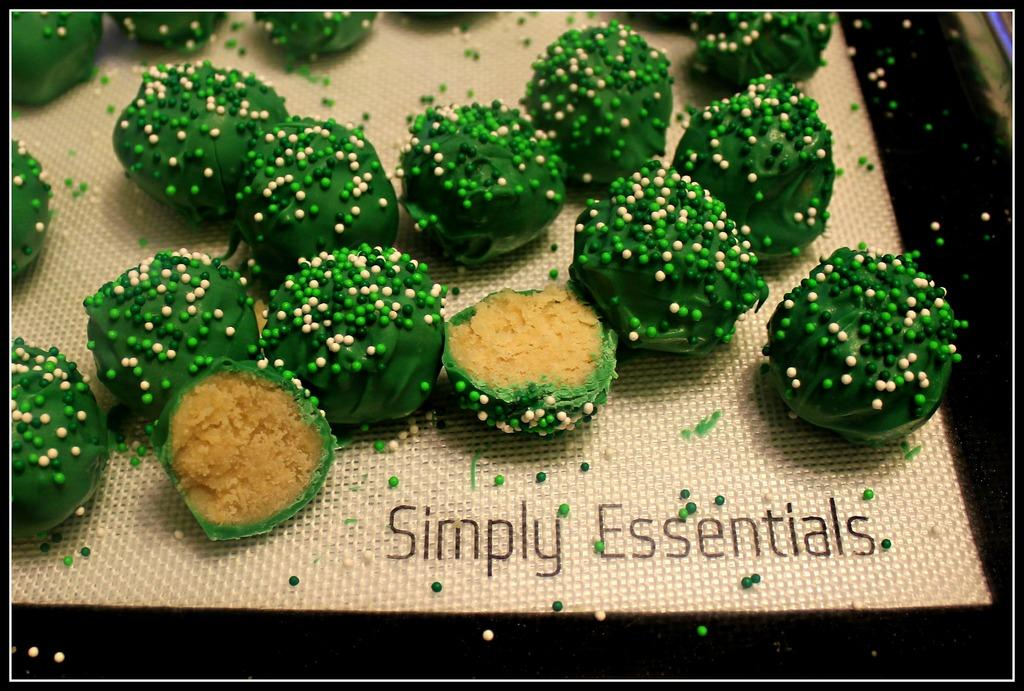What can be seen in the image related to food? There is food in the image. Is there any text present in the image? Yes, there is text at the bottom of the image. How many brothers are depicted in the image? There is no mention of brothers or any people in the image; it only features food and text. What type of reward can be seen in the image? There is no reward present in the image; it only features food and text. 